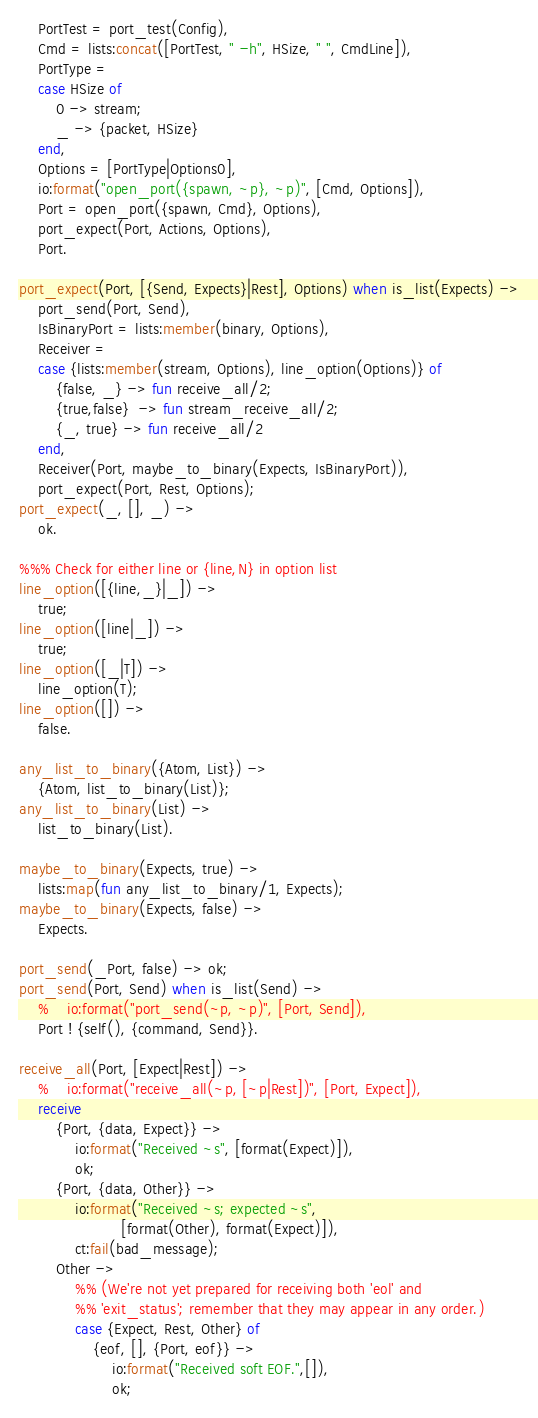Convert code to text. <code><loc_0><loc_0><loc_500><loc_500><_Erlang_>    PortTest = port_test(Config),
    Cmd = lists:concat([PortTest, " -h", HSize, " ", CmdLine]),
    PortType =
    case HSize of
        0 -> stream;
        _ -> {packet, HSize}
    end,
    Options = [PortType|Options0],
    io:format("open_port({spawn, ~p}, ~p)", [Cmd, Options]),
    Port = open_port({spawn, Cmd}, Options),
    port_expect(Port, Actions, Options),
    Port.

port_expect(Port, [{Send, Expects}|Rest], Options) when is_list(Expects) ->
    port_send(Port, Send),
    IsBinaryPort = lists:member(binary, Options),
    Receiver =
    case {lists:member(stream, Options), line_option(Options)} of
        {false, _} -> fun receive_all/2;
        {true,false}  -> fun stream_receive_all/2;
        {_, true} -> fun receive_all/2
    end,
    Receiver(Port, maybe_to_binary(Expects, IsBinaryPort)),
    port_expect(Port, Rest, Options);
port_expect(_, [], _) ->
    ok.

%%% Check for either line or {line,N} in option list
line_option([{line,_}|_]) ->
    true;
line_option([line|_]) ->
    true;
line_option([_|T]) ->
    line_option(T);
line_option([]) ->
    false.

any_list_to_binary({Atom, List}) ->
    {Atom, list_to_binary(List)};
any_list_to_binary(List) ->
    list_to_binary(List).

maybe_to_binary(Expects, true) ->
    lists:map(fun any_list_to_binary/1, Expects);
maybe_to_binary(Expects, false) ->
    Expects.

port_send(_Port, false) -> ok;
port_send(Port, Send) when is_list(Send) ->
    %    io:format("port_send(~p, ~p)", [Port, Send]),
    Port ! {self(), {command, Send}}.

receive_all(Port, [Expect|Rest]) ->
    %    io:format("receive_all(~p, [~p|Rest])", [Port, Expect]),
    receive
        {Port, {data, Expect}} ->
            io:format("Received ~s", [format(Expect)]),
            ok;
        {Port, {data, Other}} ->
            io:format("Received ~s; expected ~s",
                      [format(Other), format(Expect)]),
            ct:fail(bad_message);
        Other ->
            %% (We're not yet prepared for receiving both 'eol' and
            %% 'exit_status'; remember that they may appear in any order.)
            case {Expect, Rest, Other} of
                {eof, [], {Port, eof}} ->
                    io:format("Received soft EOF.",[]),
                    ok;</code> 